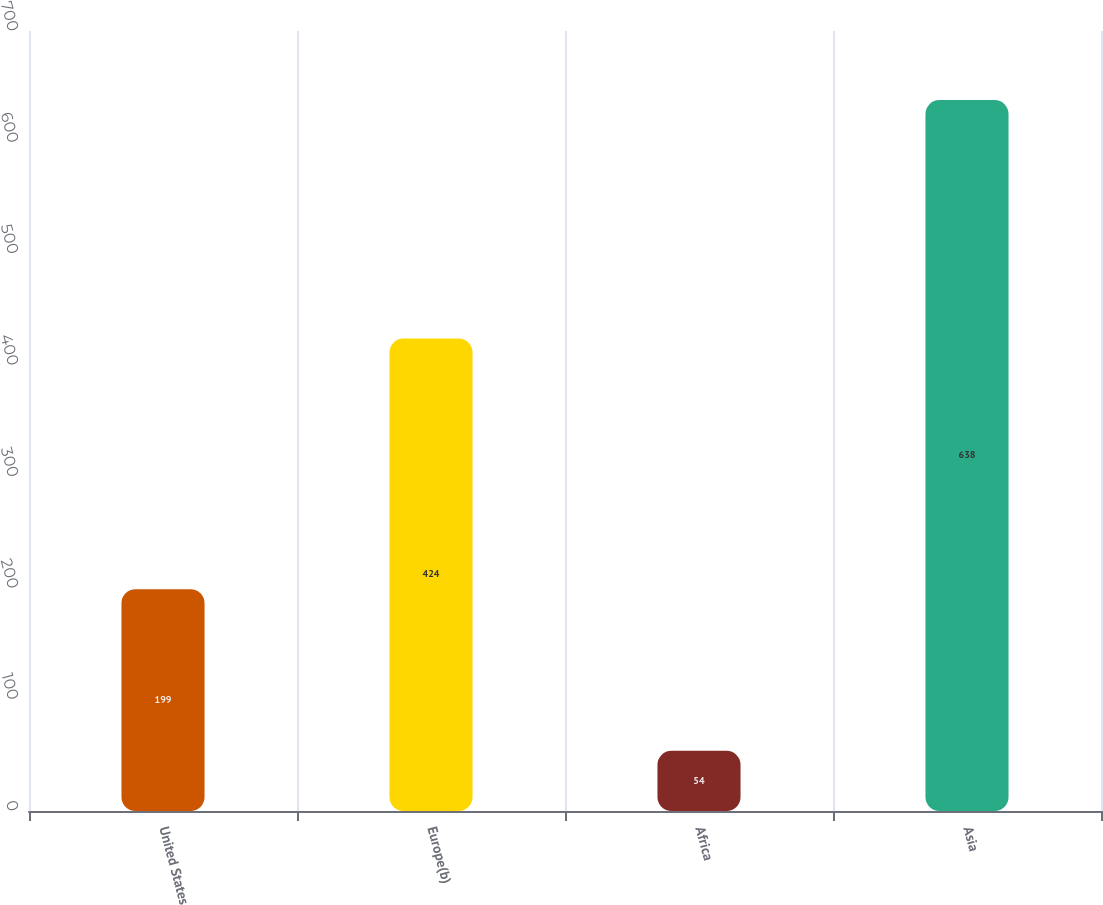Convert chart to OTSL. <chart><loc_0><loc_0><loc_500><loc_500><bar_chart><fcel>United States<fcel>Europe(b)<fcel>Africa<fcel>Asia<nl><fcel>199<fcel>424<fcel>54<fcel>638<nl></chart> 